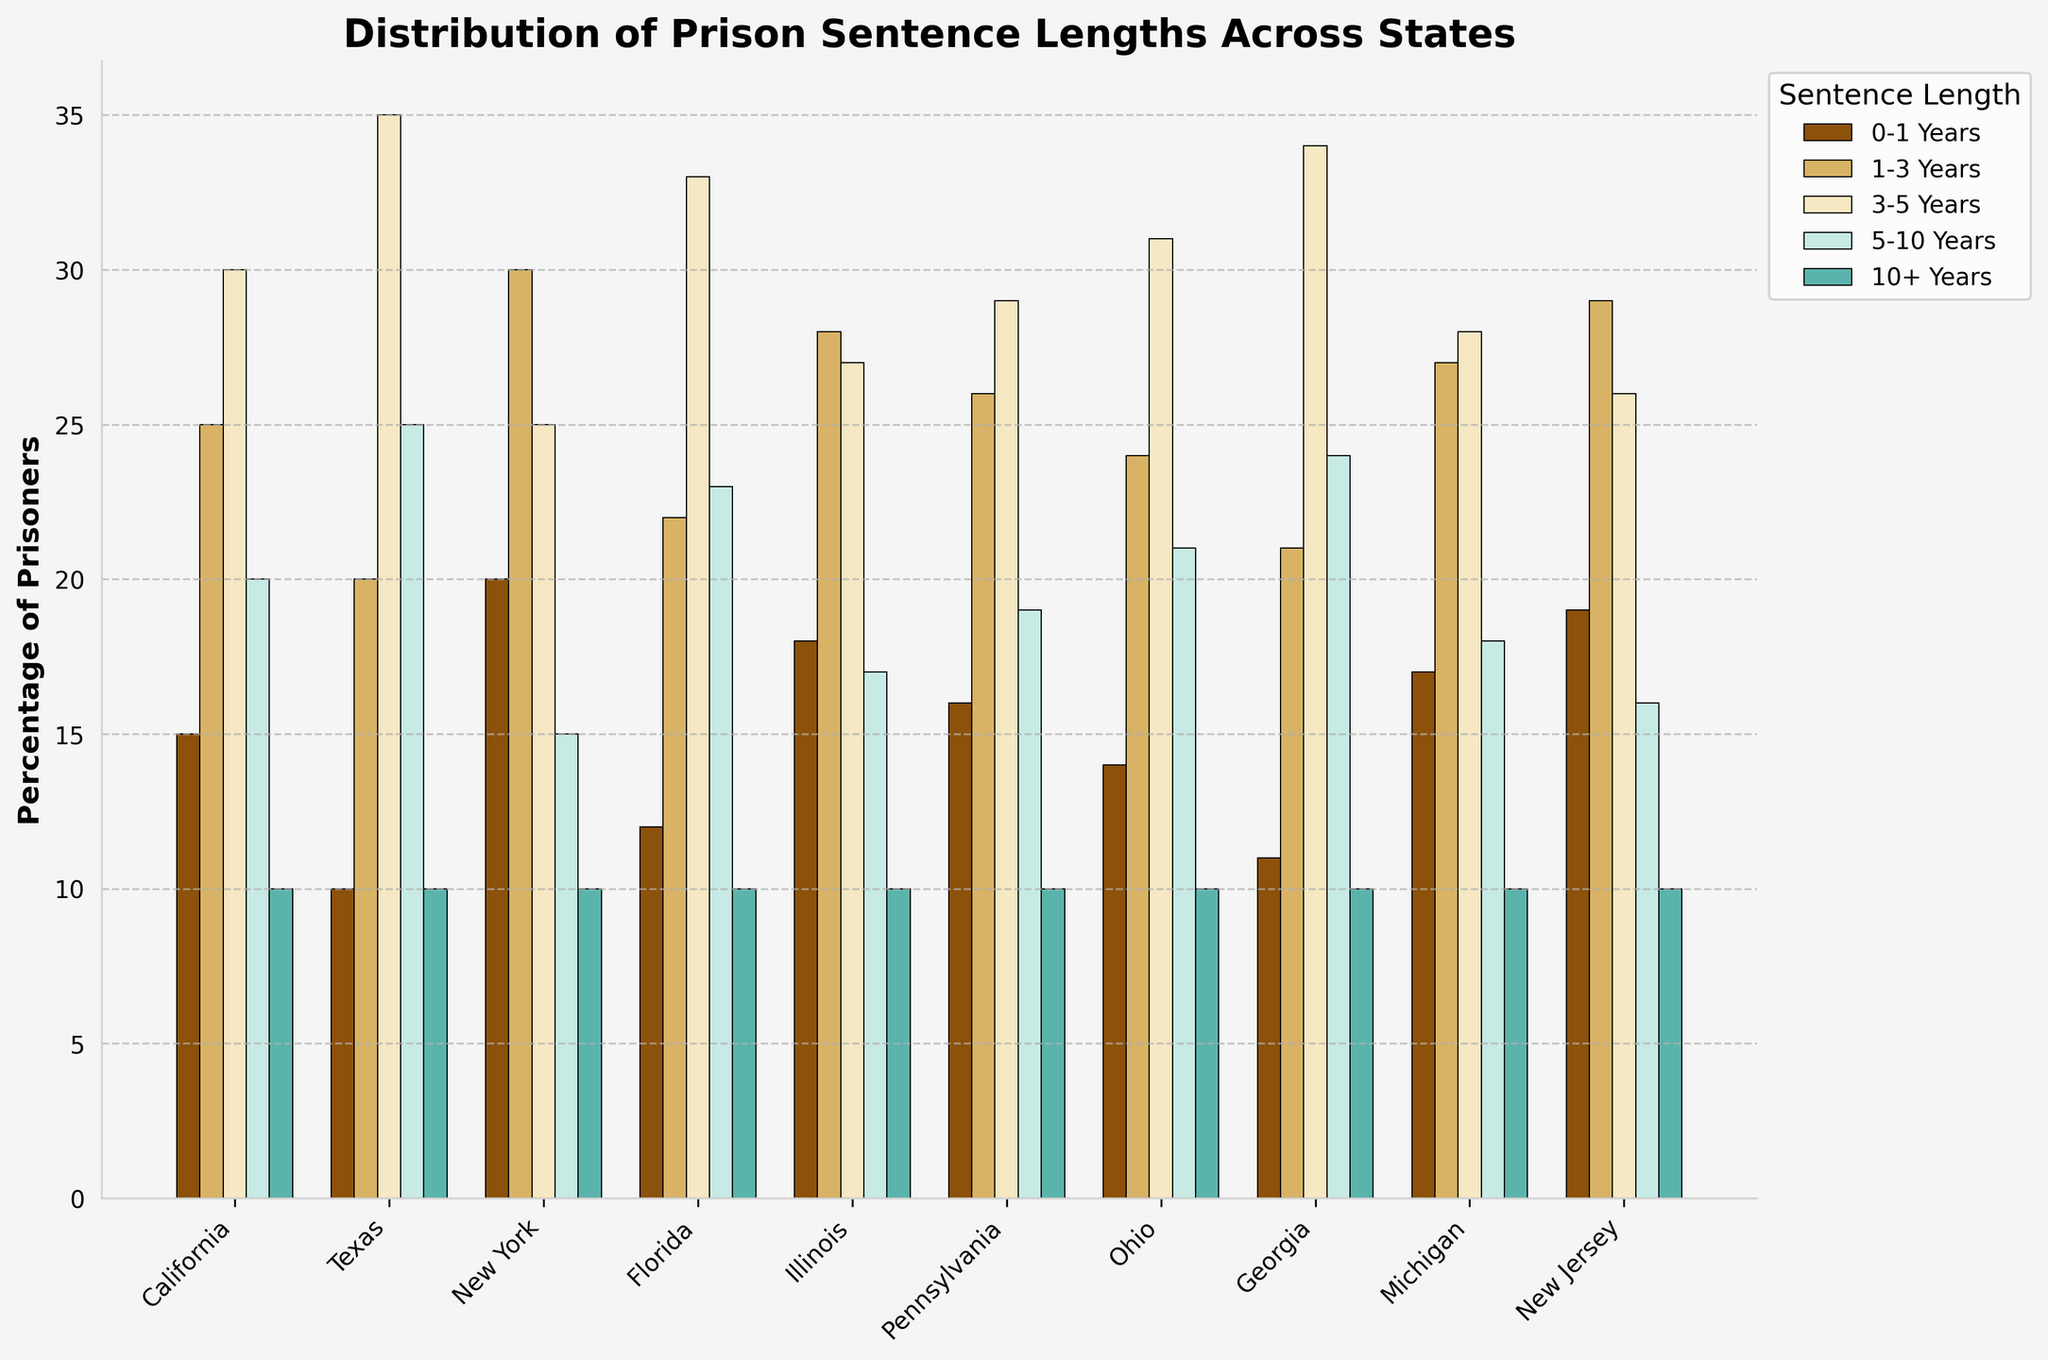What state has the highest percentage of prisoners serving 3-5 years? Identify the state with the tallest bar in the '3-5 Years' category. The heights are 30, 35, 25, 33, 27, 29, 31, 34, 28, and 26. Georgia has the highest bar at 34.
Answer: Georgia Which state has the lowest percentage of prisoners serving 0-1 years? Identify the state with the shortest bar in the '0-1 Years' category. The heights are 15, 10, 20, 12, 18, 16, 14, 11, 17, and 19. Texas has the shortest bar at 10.
Answer: Texas What is the total percentage of prisoners serving 5-10 years in Ohio and Florida? Sum the heights of the bars for Ohio and Florida in the '5-10 Years' category. For Ohio, it is 21, and for Florida, it is 23. 21 + 23 = 44.
Answer: 44 Compare the percentage of prisoners serving 10+ years across all states? Which states have the same percentage? Evaluate the heights of the bars in the '10+ Years' category. All states have 10% for '10+ Years'.
Answer: All states How does the percentage of prisoners serving 1-3 years in New York compare to that in California? Compare the heights of the bars for New York and California in the '1-3 Years' category. New York has a height of 30, and California has a height of 25. New York has a higher percentage.
Answer: New York has a higher percentage Which state has the highest number of prisoners serving 1-3 years and what is the percentage? Identify which state has the tallest bar in the '1-3 Years' category. Evaluate all bar heights for each state: 25, 20, 30, 22, 28, 26, 24, 21, 27, and 29. New York has the highest bar at 30.
Answer: New York, 30% What is the average percentage of prisoners serving 3-5 years in Texas and Illinois? Find the heights of the bars for Texas and Illinois in the '3-5 Years' category, calculate the mean. For Texas, it is 35, and for Illinois, it is 27. (35 + 27) / 2 = 31.
Answer: 31 How much higher is the percentage of prisoners serving 5-10 years in Pennsylvania compared to Michigan? Subtract the percentage for Michigan from that of Pennsylvania in the '5-10 Years' category. Pennsylvania has 19, and Michigan has 18. 19 - 18 = 1.
Answer: 1 What is the sum of the percentages of prisoners serving 5-10 years and 10+ years in New Jersey? Sum the heights of the bars for New Jersey in both the '5-10 Years' and '10+ Years' categories. For New Jersey, it is 16 and 10. 16 + 10 = 26.
Answer: 26 